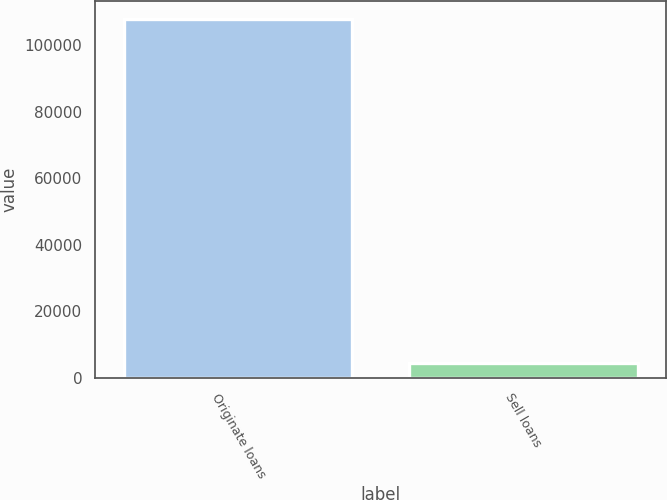<chart> <loc_0><loc_0><loc_500><loc_500><bar_chart><fcel>Originate loans<fcel>Sell loans<nl><fcel>107891<fcel>4500<nl></chart> 